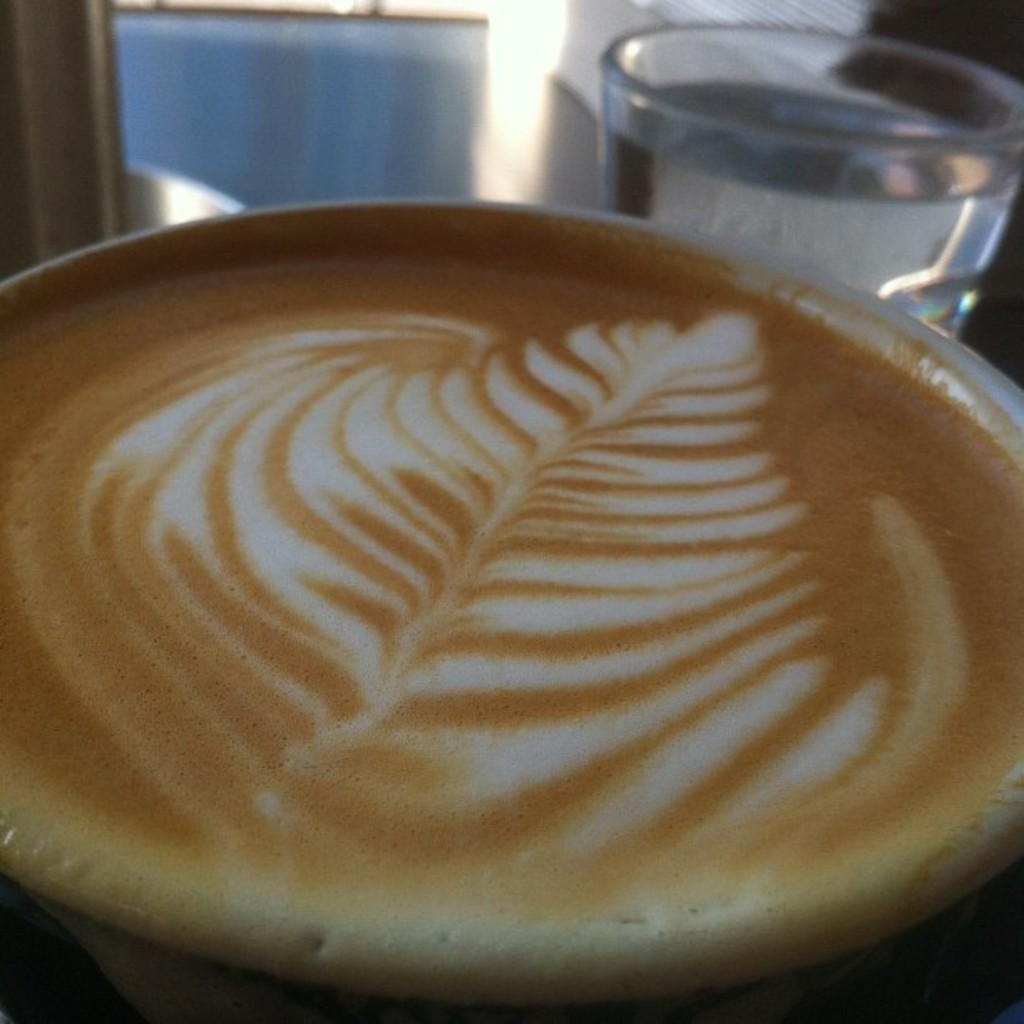What type of beverage is depicted in the image with artistic design? There is a cup of coffee with latte art in the image. What other beverage can be seen in the image? There is a glass of water in the image. How many times has the butter been folded in the image? There is no butter present in the image. Is the quicksand visible in the image? There is no quicksand present in the image. 